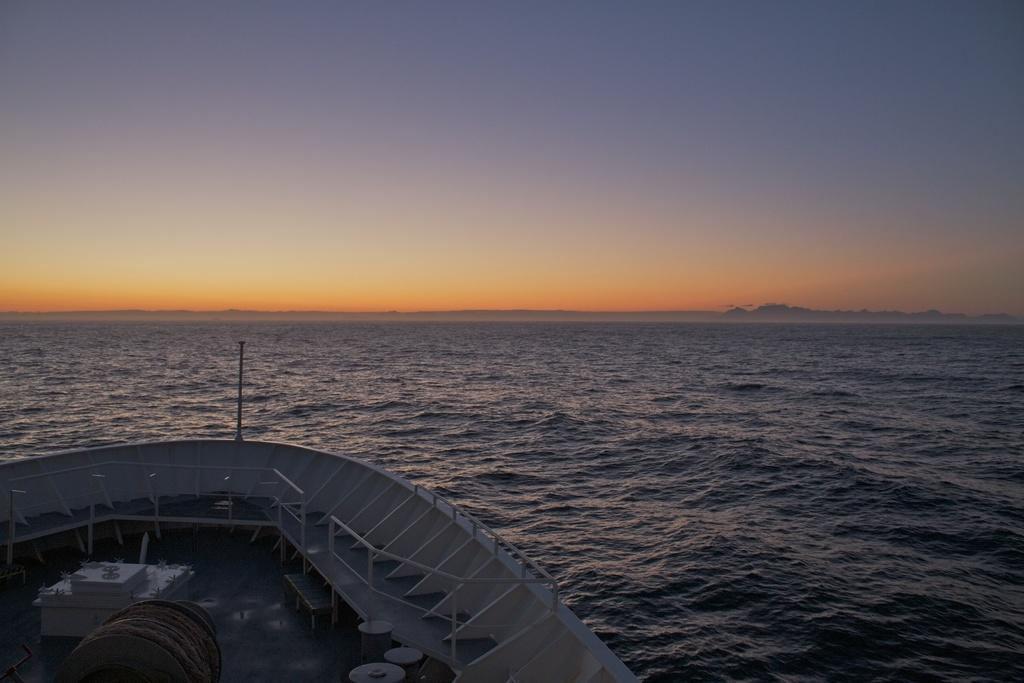What is the main subject of the image? The main subject of the image is a ship. Where is the ship located? The ship is on the water. What can be seen in the sky in the image? The sunshine is visible at the top of the image. How many vases are visible on the ship in the image? There are no vases present on the ship in the image. What type of cracker is being used as a prop in the image? There is no cracker present in the image. 